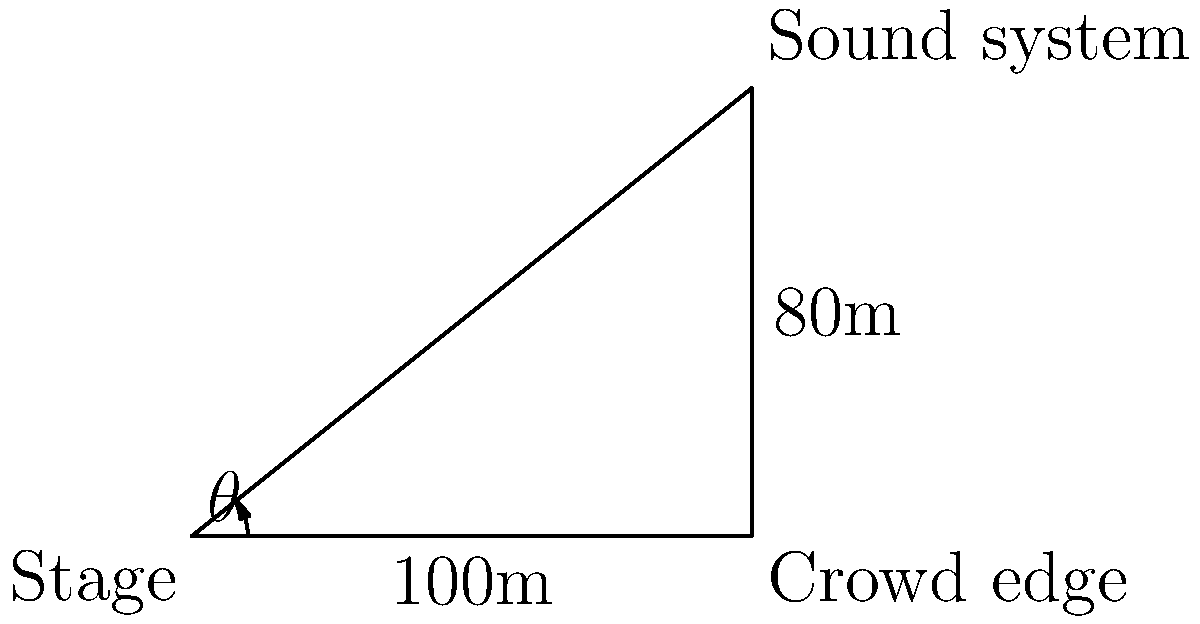At a major hip-hop festival, the DJ needs to set up the sound system for maximum crowd coverage. The stage is 100m wide, and the crowd extends 80m from the edge of the stage. What angle $\theta$ should the DJ aim the central speaker to reach the farthest point of the crowd? Let's approach this step-by-step:

1) We can treat this as a right-angled triangle problem. The stage width forms the base of the triangle, and the crowd depth forms the height.

2) We need to find the angle $\theta$ between the base (stage width) and the hypotenuse (line from stage center to farthest crowd point).

3) We can use the arctangent function to find this angle:

   $\theta = \arctan(\frac{\text{opposite}}{\text{adjacent}})$

4) The opposite side is the crowd depth (80m), and the adjacent side is half the stage width (50m, as we're aiming from the center).

5) Plugging these values into our equation:

   $\theta = \arctan(\frac{80}{50})$

6) Calculate:
   $\theta = \arctan(1.6) \approx 38.66°$

Therefore, the DJ should aim the central speaker at an angle of approximately 38.66° from the stage front for optimal coverage.
Answer: $38.66°$ 